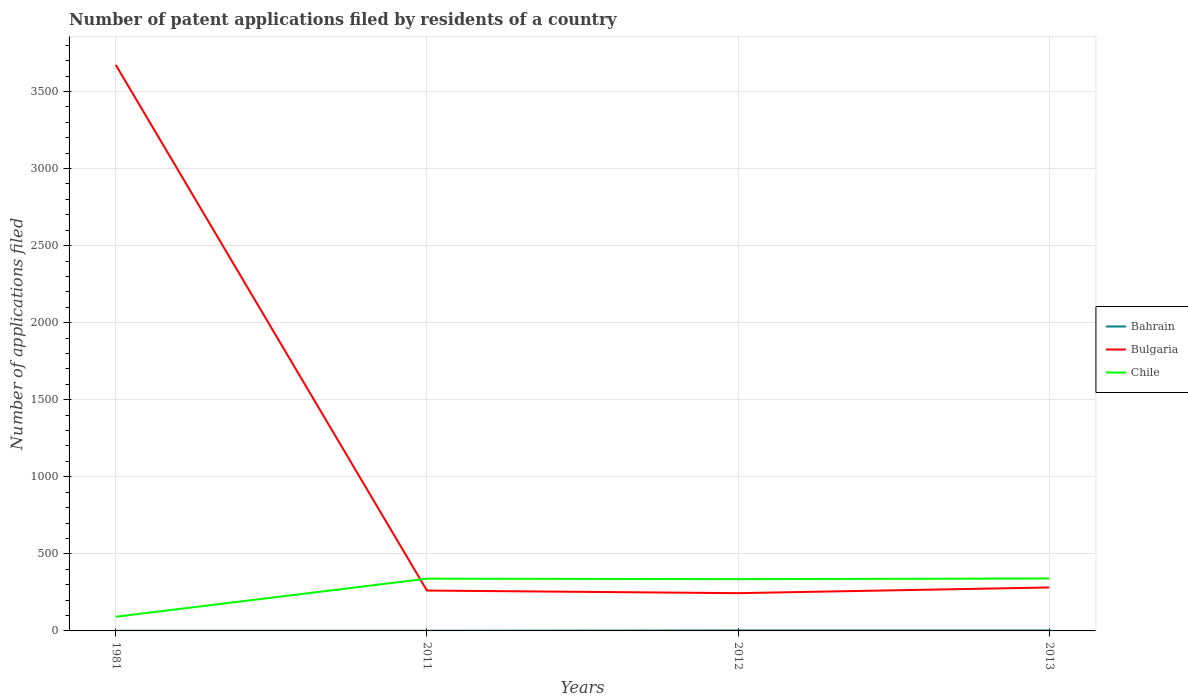How many different coloured lines are there?
Your response must be concise. 3. Across all years, what is the maximum number of applications filed in Bulgaria?
Ensure brevity in your answer.  245. In which year was the number of applications filed in Bulgaria maximum?
Make the answer very short. 2012. What is the difference between the highest and the lowest number of applications filed in Bulgaria?
Keep it short and to the point. 1. How many years are there in the graph?
Offer a very short reply. 4. Does the graph contain any zero values?
Your answer should be very brief. No. How are the legend labels stacked?
Give a very brief answer. Vertical. What is the title of the graph?
Ensure brevity in your answer.  Number of patent applications filed by residents of a country. Does "Micronesia" appear as one of the legend labels in the graph?
Give a very brief answer. No. What is the label or title of the X-axis?
Offer a terse response. Years. What is the label or title of the Y-axis?
Provide a succinct answer. Number of applications filed. What is the Number of applications filed of Bulgaria in 1981?
Offer a very short reply. 3673. What is the Number of applications filed in Chile in 1981?
Your answer should be compact. 92. What is the Number of applications filed of Bahrain in 2011?
Offer a very short reply. 1. What is the Number of applications filed of Bulgaria in 2011?
Offer a very short reply. 262. What is the Number of applications filed in Chile in 2011?
Offer a terse response. 339. What is the Number of applications filed of Bulgaria in 2012?
Provide a succinct answer. 245. What is the Number of applications filed in Chile in 2012?
Provide a succinct answer. 336. What is the Number of applications filed of Bulgaria in 2013?
Your response must be concise. 282. What is the Number of applications filed of Chile in 2013?
Your response must be concise. 340. Across all years, what is the maximum Number of applications filed in Bulgaria?
Make the answer very short. 3673. Across all years, what is the maximum Number of applications filed of Chile?
Make the answer very short. 340. Across all years, what is the minimum Number of applications filed in Bulgaria?
Provide a succinct answer. 245. Across all years, what is the minimum Number of applications filed of Chile?
Offer a terse response. 92. What is the total Number of applications filed in Bahrain in the graph?
Your answer should be very brief. 8. What is the total Number of applications filed of Bulgaria in the graph?
Ensure brevity in your answer.  4462. What is the total Number of applications filed in Chile in the graph?
Offer a terse response. 1107. What is the difference between the Number of applications filed of Bahrain in 1981 and that in 2011?
Offer a terse response. 0. What is the difference between the Number of applications filed in Bulgaria in 1981 and that in 2011?
Keep it short and to the point. 3411. What is the difference between the Number of applications filed of Chile in 1981 and that in 2011?
Provide a succinct answer. -247. What is the difference between the Number of applications filed of Bahrain in 1981 and that in 2012?
Offer a very short reply. -2. What is the difference between the Number of applications filed in Bulgaria in 1981 and that in 2012?
Offer a terse response. 3428. What is the difference between the Number of applications filed in Chile in 1981 and that in 2012?
Provide a succinct answer. -244. What is the difference between the Number of applications filed in Bahrain in 1981 and that in 2013?
Ensure brevity in your answer.  -2. What is the difference between the Number of applications filed of Bulgaria in 1981 and that in 2013?
Provide a short and direct response. 3391. What is the difference between the Number of applications filed of Chile in 1981 and that in 2013?
Your answer should be very brief. -248. What is the difference between the Number of applications filed in Bulgaria in 2011 and that in 2012?
Your response must be concise. 17. What is the difference between the Number of applications filed in Bulgaria in 2012 and that in 2013?
Offer a very short reply. -37. What is the difference between the Number of applications filed of Chile in 2012 and that in 2013?
Make the answer very short. -4. What is the difference between the Number of applications filed of Bahrain in 1981 and the Number of applications filed of Bulgaria in 2011?
Keep it short and to the point. -261. What is the difference between the Number of applications filed of Bahrain in 1981 and the Number of applications filed of Chile in 2011?
Make the answer very short. -338. What is the difference between the Number of applications filed in Bulgaria in 1981 and the Number of applications filed in Chile in 2011?
Ensure brevity in your answer.  3334. What is the difference between the Number of applications filed in Bahrain in 1981 and the Number of applications filed in Bulgaria in 2012?
Provide a succinct answer. -244. What is the difference between the Number of applications filed of Bahrain in 1981 and the Number of applications filed of Chile in 2012?
Your answer should be very brief. -335. What is the difference between the Number of applications filed in Bulgaria in 1981 and the Number of applications filed in Chile in 2012?
Keep it short and to the point. 3337. What is the difference between the Number of applications filed of Bahrain in 1981 and the Number of applications filed of Bulgaria in 2013?
Keep it short and to the point. -281. What is the difference between the Number of applications filed of Bahrain in 1981 and the Number of applications filed of Chile in 2013?
Provide a succinct answer. -339. What is the difference between the Number of applications filed of Bulgaria in 1981 and the Number of applications filed of Chile in 2013?
Give a very brief answer. 3333. What is the difference between the Number of applications filed of Bahrain in 2011 and the Number of applications filed of Bulgaria in 2012?
Provide a short and direct response. -244. What is the difference between the Number of applications filed in Bahrain in 2011 and the Number of applications filed in Chile in 2012?
Keep it short and to the point. -335. What is the difference between the Number of applications filed in Bulgaria in 2011 and the Number of applications filed in Chile in 2012?
Offer a very short reply. -74. What is the difference between the Number of applications filed in Bahrain in 2011 and the Number of applications filed in Bulgaria in 2013?
Your response must be concise. -281. What is the difference between the Number of applications filed in Bahrain in 2011 and the Number of applications filed in Chile in 2013?
Offer a very short reply. -339. What is the difference between the Number of applications filed in Bulgaria in 2011 and the Number of applications filed in Chile in 2013?
Provide a short and direct response. -78. What is the difference between the Number of applications filed of Bahrain in 2012 and the Number of applications filed of Bulgaria in 2013?
Provide a succinct answer. -279. What is the difference between the Number of applications filed in Bahrain in 2012 and the Number of applications filed in Chile in 2013?
Keep it short and to the point. -337. What is the difference between the Number of applications filed in Bulgaria in 2012 and the Number of applications filed in Chile in 2013?
Your answer should be compact. -95. What is the average Number of applications filed of Bulgaria per year?
Your response must be concise. 1115.5. What is the average Number of applications filed of Chile per year?
Provide a succinct answer. 276.75. In the year 1981, what is the difference between the Number of applications filed in Bahrain and Number of applications filed in Bulgaria?
Offer a terse response. -3672. In the year 1981, what is the difference between the Number of applications filed of Bahrain and Number of applications filed of Chile?
Give a very brief answer. -91. In the year 1981, what is the difference between the Number of applications filed of Bulgaria and Number of applications filed of Chile?
Keep it short and to the point. 3581. In the year 2011, what is the difference between the Number of applications filed of Bahrain and Number of applications filed of Bulgaria?
Keep it short and to the point. -261. In the year 2011, what is the difference between the Number of applications filed of Bahrain and Number of applications filed of Chile?
Keep it short and to the point. -338. In the year 2011, what is the difference between the Number of applications filed of Bulgaria and Number of applications filed of Chile?
Offer a very short reply. -77. In the year 2012, what is the difference between the Number of applications filed of Bahrain and Number of applications filed of Bulgaria?
Offer a terse response. -242. In the year 2012, what is the difference between the Number of applications filed of Bahrain and Number of applications filed of Chile?
Provide a succinct answer. -333. In the year 2012, what is the difference between the Number of applications filed in Bulgaria and Number of applications filed in Chile?
Ensure brevity in your answer.  -91. In the year 2013, what is the difference between the Number of applications filed in Bahrain and Number of applications filed in Bulgaria?
Your answer should be compact. -279. In the year 2013, what is the difference between the Number of applications filed of Bahrain and Number of applications filed of Chile?
Provide a short and direct response. -337. In the year 2013, what is the difference between the Number of applications filed of Bulgaria and Number of applications filed of Chile?
Your answer should be compact. -58. What is the ratio of the Number of applications filed in Bahrain in 1981 to that in 2011?
Offer a terse response. 1. What is the ratio of the Number of applications filed of Bulgaria in 1981 to that in 2011?
Your response must be concise. 14.02. What is the ratio of the Number of applications filed of Chile in 1981 to that in 2011?
Give a very brief answer. 0.27. What is the ratio of the Number of applications filed of Bahrain in 1981 to that in 2012?
Ensure brevity in your answer.  0.33. What is the ratio of the Number of applications filed of Bulgaria in 1981 to that in 2012?
Your answer should be very brief. 14.99. What is the ratio of the Number of applications filed of Chile in 1981 to that in 2012?
Offer a terse response. 0.27. What is the ratio of the Number of applications filed of Bulgaria in 1981 to that in 2013?
Offer a very short reply. 13.02. What is the ratio of the Number of applications filed of Chile in 1981 to that in 2013?
Provide a short and direct response. 0.27. What is the ratio of the Number of applications filed in Bahrain in 2011 to that in 2012?
Offer a terse response. 0.33. What is the ratio of the Number of applications filed in Bulgaria in 2011 to that in 2012?
Provide a short and direct response. 1.07. What is the ratio of the Number of applications filed in Chile in 2011 to that in 2012?
Ensure brevity in your answer.  1.01. What is the ratio of the Number of applications filed of Bahrain in 2011 to that in 2013?
Your answer should be very brief. 0.33. What is the ratio of the Number of applications filed of Bulgaria in 2011 to that in 2013?
Offer a terse response. 0.93. What is the ratio of the Number of applications filed in Chile in 2011 to that in 2013?
Ensure brevity in your answer.  1. What is the ratio of the Number of applications filed in Bulgaria in 2012 to that in 2013?
Keep it short and to the point. 0.87. What is the difference between the highest and the second highest Number of applications filed of Bulgaria?
Your response must be concise. 3391. What is the difference between the highest and the second highest Number of applications filed in Chile?
Your answer should be very brief. 1. What is the difference between the highest and the lowest Number of applications filed of Bulgaria?
Make the answer very short. 3428. What is the difference between the highest and the lowest Number of applications filed of Chile?
Make the answer very short. 248. 